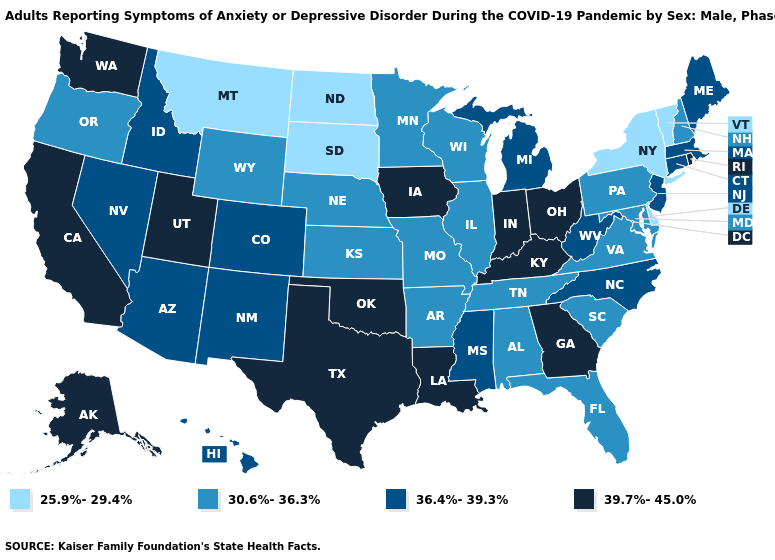Does Florida have the same value as North Dakota?
Be succinct. No. Name the states that have a value in the range 39.7%-45.0%?
Short answer required. Alaska, California, Georgia, Indiana, Iowa, Kentucky, Louisiana, Ohio, Oklahoma, Rhode Island, Texas, Utah, Washington. Does the first symbol in the legend represent the smallest category?
Write a very short answer. Yes. Which states have the highest value in the USA?
Give a very brief answer. Alaska, California, Georgia, Indiana, Iowa, Kentucky, Louisiana, Ohio, Oklahoma, Rhode Island, Texas, Utah, Washington. Name the states that have a value in the range 30.6%-36.3%?
Write a very short answer. Alabama, Arkansas, Florida, Illinois, Kansas, Maryland, Minnesota, Missouri, Nebraska, New Hampshire, Oregon, Pennsylvania, South Carolina, Tennessee, Virginia, Wisconsin, Wyoming. What is the value of Kansas?
Quick response, please. 30.6%-36.3%. Among the states that border Virginia , does Kentucky have the lowest value?
Concise answer only. No. Among the states that border Wisconsin , which have the lowest value?
Concise answer only. Illinois, Minnesota. What is the value of Delaware?
Quick response, please. 25.9%-29.4%. What is the value of New York?
Give a very brief answer. 25.9%-29.4%. Name the states that have a value in the range 25.9%-29.4%?
Quick response, please. Delaware, Montana, New York, North Dakota, South Dakota, Vermont. Does New Hampshire have the highest value in the Northeast?
Concise answer only. No. How many symbols are there in the legend?
Be succinct. 4. What is the value of Hawaii?
Concise answer only. 36.4%-39.3%. What is the value of Massachusetts?
Quick response, please. 36.4%-39.3%. 